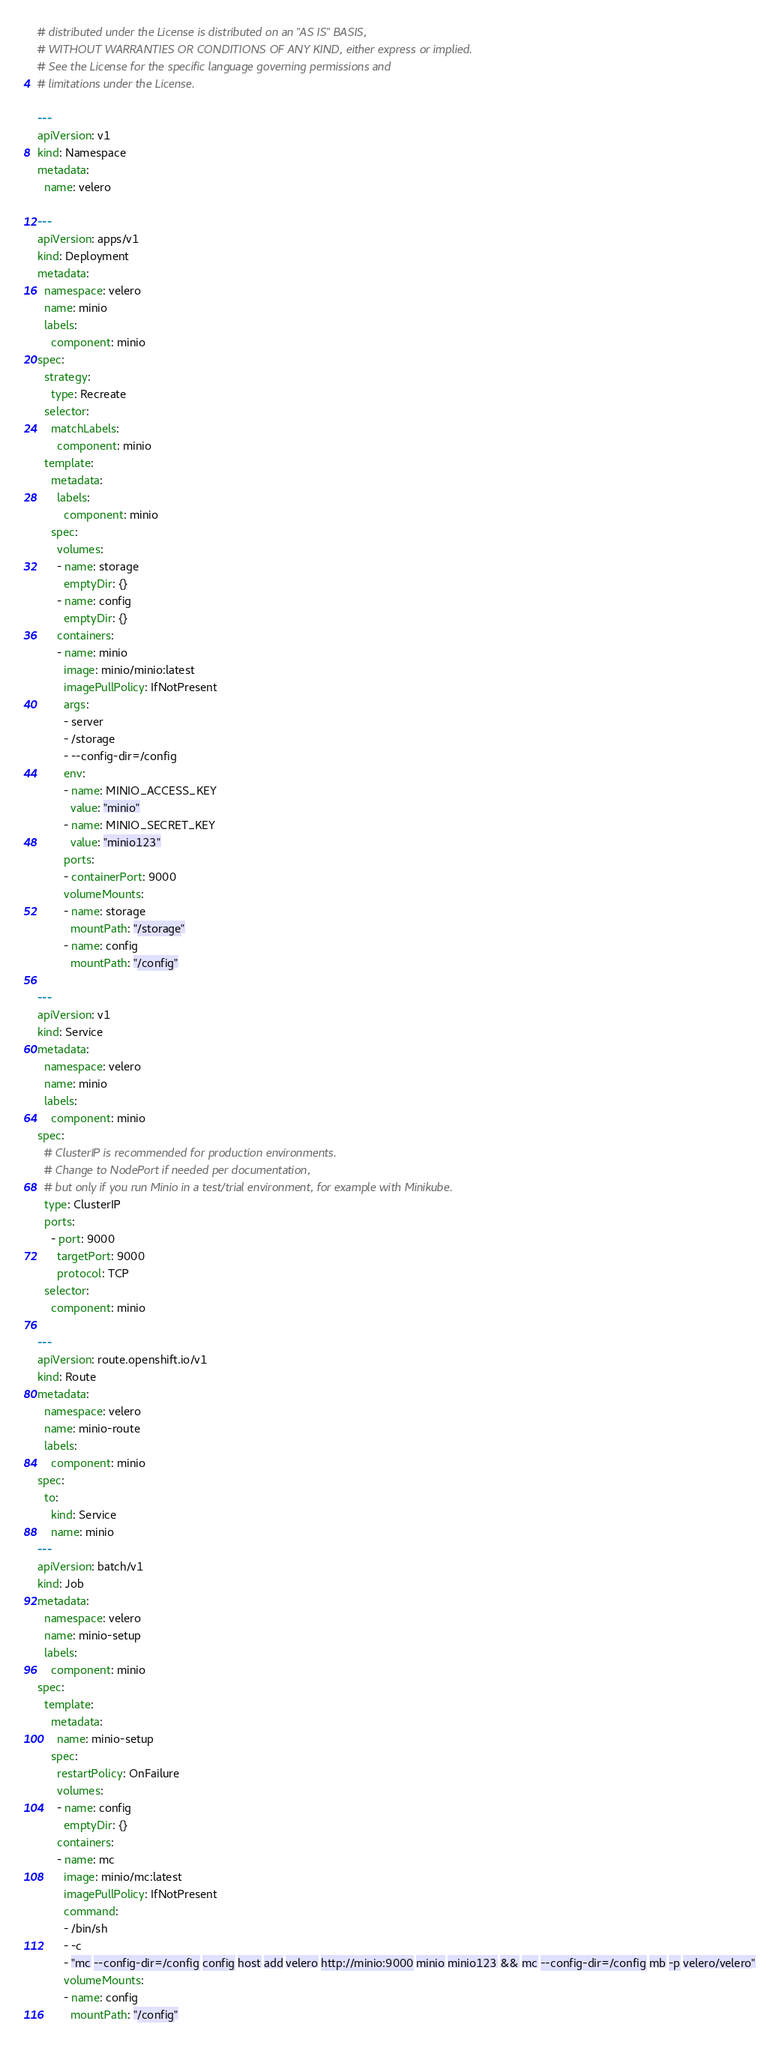<code> <loc_0><loc_0><loc_500><loc_500><_YAML_># distributed under the License is distributed on an "AS IS" BASIS,
# WITHOUT WARRANTIES OR CONDITIONS OF ANY KIND, either express or implied.
# See the License for the specific language governing permissions and
# limitations under the License.

---
apiVersion: v1
kind: Namespace
metadata:
  name: velero

---
apiVersion: apps/v1
kind: Deployment
metadata:
  namespace: velero
  name: minio
  labels:
    component: minio
spec:
  strategy:
    type: Recreate
  selector:
    matchLabels:
      component: minio
  template:
    metadata:
      labels:
        component: minio
    spec:
      volumes:
      - name: storage
        emptyDir: {}
      - name: config
        emptyDir: {}
      containers:
      - name: minio
        image: minio/minio:latest
        imagePullPolicy: IfNotPresent
        args:
        - server
        - /storage
        - --config-dir=/config
        env:
        - name: MINIO_ACCESS_KEY
          value: "minio"
        - name: MINIO_SECRET_KEY
          value: "minio123"
        ports:
        - containerPort: 9000
        volumeMounts:
        - name: storage
          mountPath: "/storage"
        - name: config
          mountPath: "/config"

---
apiVersion: v1
kind: Service
metadata:
  namespace: velero
  name: minio
  labels:
    component: minio
spec:
  # ClusterIP is recommended for production environments.
  # Change to NodePort if needed per documentation,
  # but only if you run Minio in a test/trial environment, for example with Minikube.
  type: ClusterIP
  ports:
    - port: 9000
      targetPort: 9000
      protocol: TCP
  selector:
    component: minio

---
apiVersion: route.openshift.io/v1
kind: Route
metadata:
  namespace: velero
  name: minio-route
  labels:
    component: minio
spec:
  to:
    kind: Service
    name: minio
---
apiVersion: batch/v1
kind: Job
metadata:
  namespace: velero
  name: minio-setup
  labels:
    component: minio
spec:
  template:
    metadata:
      name: minio-setup
    spec:
      restartPolicy: OnFailure
      volumes:
      - name: config
        emptyDir: {}
      containers:
      - name: mc
        image: minio/mc:latest
        imagePullPolicy: IfNotPresent
        command:
        - /bin/sh
        - -c
        - "mc --config-dir=/config config host add velero http://minio:9000 minio minio123 && mc --config-dir=/config mb -p velero/velero"
        volumeMounts:
        - name: config
          mountPath: "/config"
</code> 